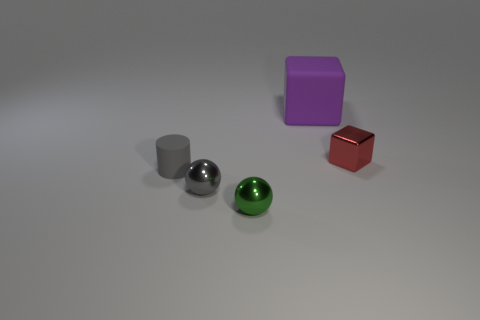There is a small metal sphere behind the tiny green shiny object; is it the same color as the small matte cylinder?
Make the answer very short. Yes. Are there more purple rubber objects right of the green object than tiny gray rubber things behind the large purple rubber block?
Provide a succinct answer. Yes. Are there more red rubber blocks than spheres?
Ensure brevity in your answer.  No. How big is the object that is both behind the tiny rubber cylinder and on the left side of the red metallic thing?
Provide a short and direct response. Large. What is the shape of the green metallic object?
Ensure brevity in your answer.  Sphere. Are there any other things that have the same size as the purple rubber block?
Your answer should be very brief. No. Is the number of small objects that are to the left of the big matte block greater than the number of red metallic cubes?
Offer a very short reply. Yes. There is a matte object in front of the object that is behind the cube on the right side of the big purple object; what shape is it?
Provide a succinct answer. Cylinder. Is the size of the cube in front of the purple matte block the same as the tiny green ball?
Your answer should be compact. Yes. There is a thing that is both behind the small rubber object and in front of the big rubber block; what shape is it?
Ensure brevity in your answer.  Cube. 